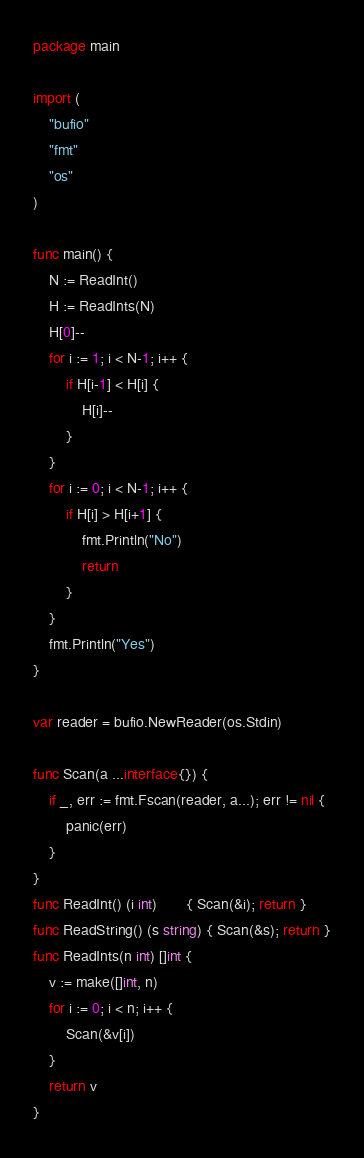<code> <loc_0><loc_0><loc_500><loc_500><_Go_>package main

import (
	"bufio"
	"fmt"
	"os"
)

func main() {
	N := ReadInt()
	H := ReadInts(N)
	H[0]--
	for i := 1; i < N-1; i++ {
		if H[i-1] < H[i] {
			H[i]--
		}
	}
	for i := 0; i < N-1; i++ {
		if H[i] > H[i+1] {
			fmt.Println("No")
			return
		}
	}
	fmt.Println("Yes")
}

var reader = bufio.NewReader(os.Stdin)

func Scan(a ...interface{}) {
	if _, err := fmt.Fscan(reader, a...); err != nil {
		panic(err)
	}
}
func ReadInt() (i int)       { Scan(&i); return }
func ReadString() (s string) { Scan(&s); return }
func ReadInts(n int) []int {
	v := make([]int, n)
	for i := 0; i < n; i++ {
		Scan(&v[i])
	}
	return v
}
</code> 